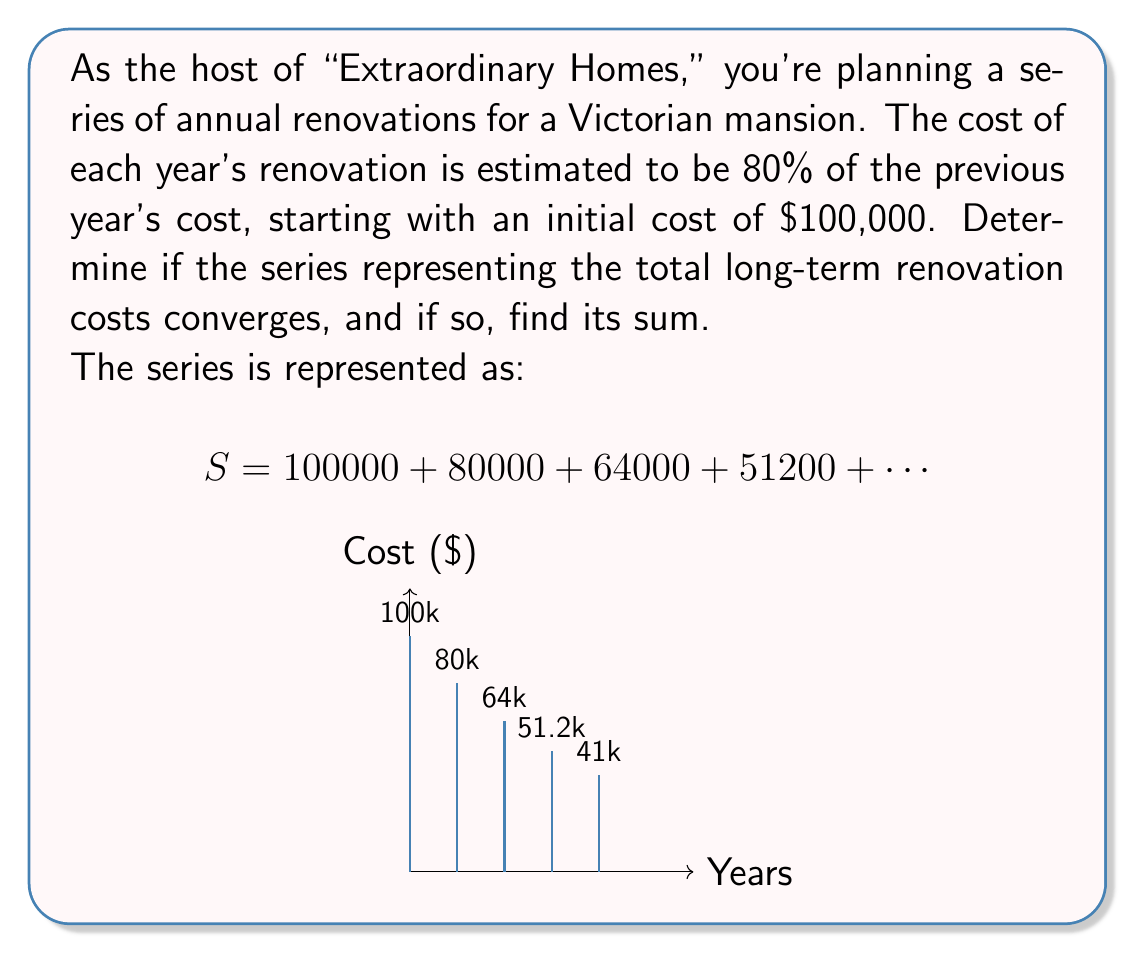Help me with this question. Let's approach this step-by-step:

1) First, we need to recognize that this is a geometric series with:
   - First term $a = 100000$
   - Common ratio $r = 0.8$ (each term is 80% of the previous)

2) For a geometric series to converge, we need $|r| < 1$. In this case:
   $|r| = |0.8| = 0.8 < 1$, so the series converges.

3) For a convergent geometric series, the sum is given by the formula:
   $$S_{\infty} = \frac{a}{1-r}$$
   where $S_{\infty}$ is the sum of the infinite series, $a$ is the first term, and $r$ is the common ratio.

4) Substituting our values:
   $$S_{\infty} = \frac{100000}{1-0.8} = \frac{100000}{0.2}$$

5) Calculating:
   $$S_{\infty} = 500000$$

Therefore, the series converges, and the sum represents the total long-term renovation costs if continued indefinitely.
Answer: The series converges to $500,000. 